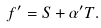<formula> <loc_0><loc_0><loc_500><loc_500>f ^ { \prime } = S + \alpha ^ { \prime } T .</formula> 